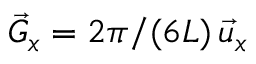Convert formula to latex. <formula><loc_0><loc_0><loc_500><loc_500>\vec { G } _ { x } = 2 \pi / ( 6 L ) \, \vec { u } _ { x }</formula> 